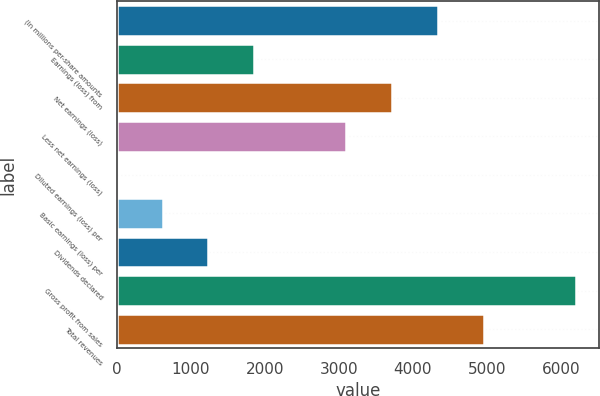<chart> <loc_0><loc_0><loc_500><loc_500><bar_chart><fcel>(In millions per-share amounts<fcel>Earnings (loss) from<fcel>Net earnings (loss)<fcel>Less net earnings (loss)<fcel>Diluted earnings (loss) per<fcel>Basic earnings (loss) per<fcel>Dividends declared<fcel>Gross profit from sales<fcel>Total revenues<nl><fcel>4341.41<fcel>1860.65<fcel>3721.22<fcel>3101.03<fcel>0.08<fcel>620.27<fcel>1240.46<fcel>6202<fcel>4961.6<nl></chart> 